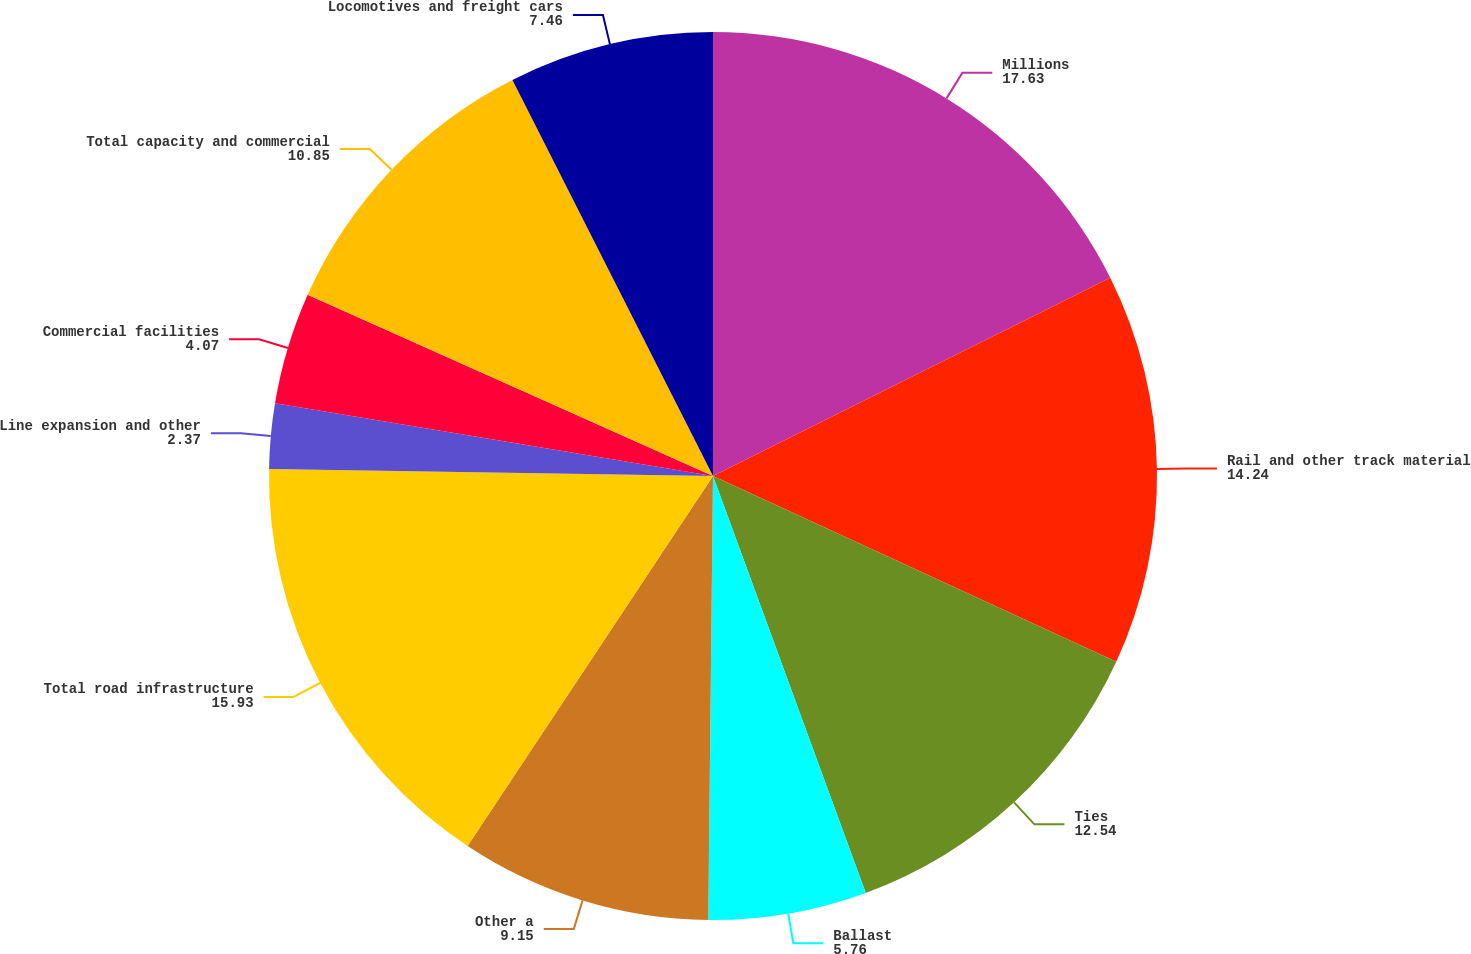<chart> <loc_0><loc_0><loc_500><loc_500><pie_chart><fcel>Millions<fcel>Rail and other track material<fcel>Ties<fcel>Ballast<fcel>Other a<fcel>Total road infrastructure<fcel>Line expansion and other<fcel>Commercial facilities<fcel>Total capacity and commercial<fcel>Locomotives and freight cars<nl><fcel>17.63%<fcel>14.24%<fcel>12.54%<fcel>5.76%<fcel>9.15%<fcel>15.93%<fcel>2.37%<fcel>4.07%<fcel>10.85%<fcel>7.46%<nl></chart> 